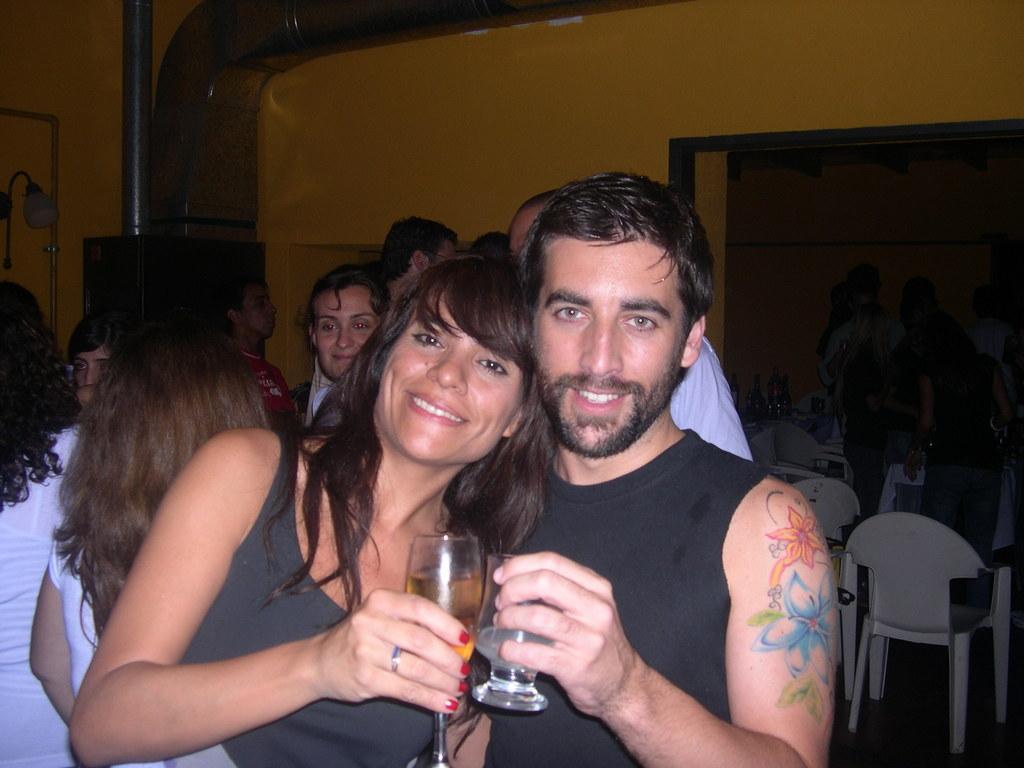How would you summarize this image in a sentence or two? In the image we can see there are people who are standing and in front there are two people who are holding wine glasses in their hand. 